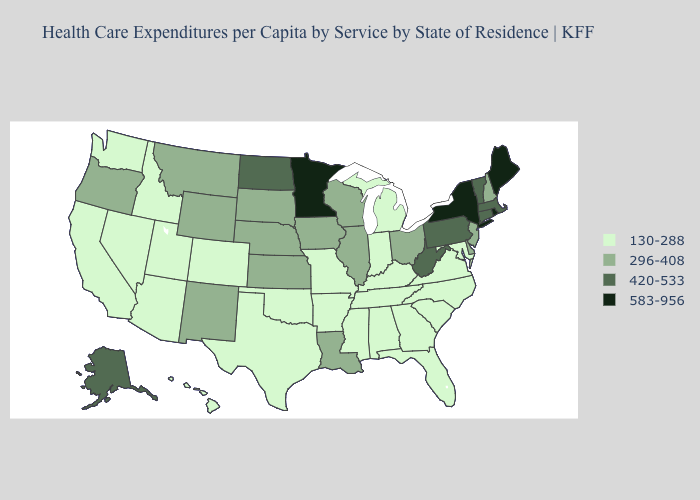Name the states that have a value in the range 420-533?
Be succinct. Alaska, Connecticut, Massachusetts, North Dakota, Pennsylvania, Vermont, West Virginia. Name the states that have a value in the range 130-288?
Keep it brief. Alabama, Arizona, Arkansas, California, Colorado, Florida, Georgia, Hawaii, Idaho, Indiana, Kentucky, Maryland, Michigan, Mississippi, Missouri, Nevada, North Carolina, Oklahoma, South Carolina, Tennessee, Texas, Utah, Virginia, Washington. What is the lowest value in states that border Tennessee?
Be succinct. 130-288. Among the states that border Kansas , does Nebraska have the highest value?
Short answer required. Yes. Does Minnesota have the lowest value in the MidWest?
Answer briefly. No. What is the value of Utah?
Quick response, please. 130-288. How many symbols are there in the legend?
Answer briefly. 4. Which states have the lowest value in the USA?
Write a very short answer. Alabama, Arizona, Arkansas, California, Colorado, Florida, Georgia, Hawaii, Idaho, Indiana, Kentucky, Maryland, Michigan, Mississippi, Missouri, Nevada, North Carolina, Oklahoma, South Carolina, Tennessee, Texas, Utah, Virginia, Washington. Among the states that border Illinois , does Kentucky have the highest value?
Concise answer only. No. What is the value of North Carolina?
Concise answer only. 130-288. Among the states that border Texas , does New Mexico have the lowest value?
Write a very short answer. No. Does Tennessee have a lower value than Iowa?
Quick response, please. Yes. What is the value of Pennsylvania?
Concise answer only. 420-533. Does Minnesota have the highest value in the MidWest?
Keep it brief. Yes. Does Missouri have the lowest value in the MidWest?
Concise answer only. Yes. 